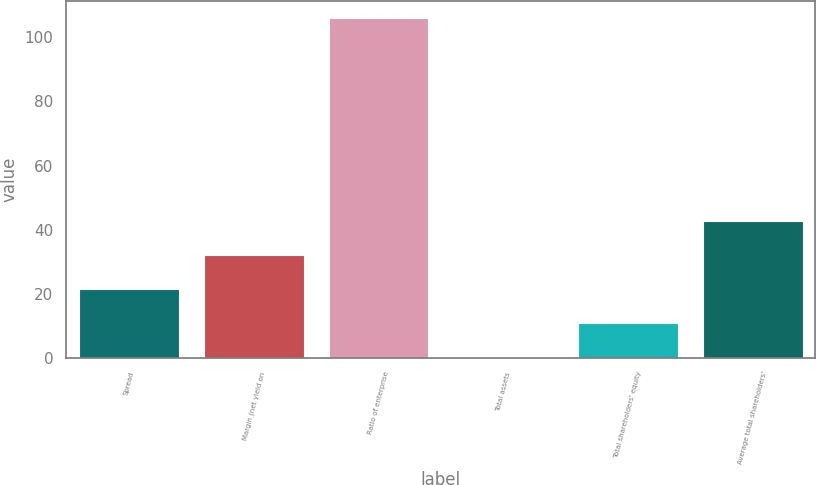Convert chart to OTSL. <chart><loc_0><loc_0><loc_500><loc_500><bar_chart><fcel>Spread<fcel>Margin (net yield on<fcel>Ratio of enterprise<fcel>Total assets<fcel>Total shareholders' equity<fcel>Average total shareholders'<nl><fcel>21.41<fcel>32<fcel>106.09<fcel>0.23<fcel>10.82<fcel>42.59<nl></chart> 